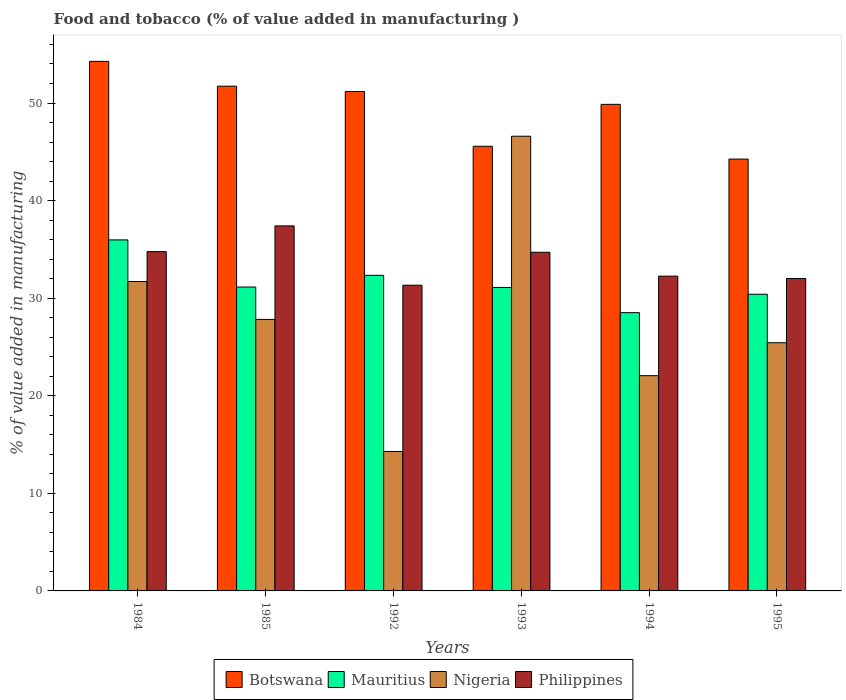How many bars are there on the 3rd tick from the right?
Make the answer very short. 4. What is the value added in manufacturing food and tobacco in Philippines in 1995?
Your answer should be very brief. 32.01. Across all years, what is the maximum value added in manufacturing food and tobacco in Nigeria?
Provide a short and direct response. 46.6. Across all years, what is the minimum value added in manufacturing food and tobacco in Mauritius?
Provide a succinct answer. 28.52. In which year was the value added in manufacturing food and tobacco in Mauritius maximum?
Your answer should be very brief. 1984. In which year was the value added in manufacturing food and tobacco in Mauritius minimum?
Provide a short and direct response. 1994. What is the total value added in manufacturing food and tobacco in Mauritius in the graph?
Your answer should be compact. 189.47. What is the difference between the value added in manufacturing food and tobacco in Philippines in 1985 and that in 1993?
Ensure brevity in your answer.  2.7. What is the difference between the value added in manufacturing food and tobacco in Botswana in 1992 and the value added in manufacturing food and tobacco in Mauritius in 1985?
Offer a very short reply. 20.04. What is the average value added in manufacturing food and tobacco in Nigeria per year?
Offer a very short reply. 27.99. In the year 1994, what is the difference between the value added in manufacturing food and tobacco in Nigeria and value added in manufacturing food and tobacco in Mauritius?
Make the answer very short. -6.46. What is the ratio of the value added in manufacturing food and tobacco in Philippines in 1985 to that in 1994?
Provide a short and direct response. 1.16. Is the value added in manufacturing food and tobacco in Mauritius in 1984 less than that in 1993?
Your answer should be very brief. No. Is the difference between the value added in manufacturing food and tobacco in Nigeria in 1992 and 1994 greater than the difference between the value added in manufacturing food and tobacco in Mauritius in 1992 and 1994?
Ensure brevity in your answer.  No. What is the difference between the highest and the second highest value added in manufacturing food and tobacco in Nigeria?
Keep it short and to the point. 14.89. What is the difference between the highest and the lowest value added in manufacturing food and tobacco in Nigeria?
Provide a short and direct response. 32.3. In how many years, is the value added in manufacturing food and tobacco in Nigeria greater than the average value added in manufacturing food and tobacco in Nigeria taken over all years?
Keep it short and to the point. 2. Is the sum of the value added in manufacturing food and tobacco in Botswana in 1993 and 1994 greater than the maximum value added in manufacturing food and tobacco in Philippines across all years?
Provide a short and direct response. Yes. What does the 3rd bar from the right in 1985 represents?
Offer a very short reply. Mauritius. Is it the case that in every year, the sum of the value added in manufacturing food and tobacco in Nigeria and value added in manufacturing food and tobacco in Botswana is greater than the value added in manufacturing food and tobacco in Mauritius?
Offer a very short reply. Yes. How many bars are there?
Your answer should be very brief. 24. How many years are there in the graph?
Ensure brevity in your answer.  6. What is the difference between two consecutive major ticks on the Y-axis?
Provide a short and direct response. 10. How many legend labels are there?
Your answer should be very brief. 4. How are the legend labels stacked?
Keep it short and to the point. Horizontal. What is the title of the graph?
Provide a short and direct response. Food and tobacco (% of value added in manufacturing ). What is the label or title of the Y-axis?
Provide a succinct answer. % of value added in manufacturing. What is the % of value added in manufacturing in Botswana in 1984?
Provide a succinct answer. 54.27. What is the % of value added in manufacturing in Mauritius in 1984?
Provide a succinct answer. 35.97. What is the % of value added in manufacturing of Nigeria in 1984?
Your answer should be compact. 31.71. What is the % of value added in manufacturing in Philippines in 1984?
Make the answer very short. 34.77. What is the % of value added in manufacturing of Botswana in 1985?
Your response must be concise. 51.72. What is the % of value added in manufacturing in Mauritius in 1985?
Your response must be concise. 31.14. What is the % of value added in manufacturing in Nigeria in 1985?
Offer a terse response. 27.82. What is the % of value added in manufacturing of Philippines in 1985?
Make the answer very short. 37.41. What is the % of value added in manufacturing of Botswana in 1992?
Give a very brief answer. 51.18. What is the % of value added in manufacturing of Mauritius in 1992?
Ensure brevity in your answer.  32.34. What is the % of value added in manufacturing in Nigeria in 1992?
Keep it short and to the point. 14.29. What is the % of value added in manufacturing in Philippines in 1992?
Provide a succinct answer. 31.33. What is the % of value added in manufacturing in Botswana in 1993?
Provide a succinct answer. 45.56. What is the % of value added in manufacturing in Mauritius in 1993?
Give a very brief answer. 31.1. What is the % of value added in manufacturing in Nigeria in 1993?
Ensure brevity in your answer.  46.6. What is the % of value added in manufacturing in Philippines in 1993?
Your answer should be compact. 34.7. What is the % of value added in manufacturing in Botswana in 1994?
Keep it short and to the point. 49.86. What is the % of value added in manufacturing in Mauritius in 1994?
Your response must be concise. 28.52. What is the % of value added in manufacturing in Nigeria in 1994?
Give a very brief answer. 22.06. What is the % of value added in manufacturing in Philippines in 1994?
Provide a succinct answer. 32.26. What is the % of value added in manufacturing of Botswana in 1995?
Your answer should be very brief. 44.26. What is the % of value added in manufacturing of Mauritius in 1995?
Keep it short and to the point. 30.4. What is the % of value added in manufacturing of Nigeria in 1995?
Ensure brevity in your answer.  25.43. What is the % of value added in manufacturing of Philippines in 1995?
Provide a succinct answer. 32.01. Across all years, what is the maximum % of value added in manufacturing in Botswana?
Ensure brevity in your answer.  54.27. Across all years, what is the maximum % of value added in manufacturing in Mauritius?
Keep it short and to the point. 35.97. Across all years, what is the maximum % of value added in manufacturing in Nigeria?
Offer a terse response. 46.6. Across all years, what is the maximum % of value added in manufacturing of Philippines?
Provide a short and direct response. 37.41. Across all years, what is the minimum % of value added in manufacturing in Botswana?
Provide a succinct answer. 44.26. Across all years, what is the minimum % of value added in manufacturing in Mauritius?
Your answer should be very brief. 28.52. Across all years, what is the minimum % of value added in manufacturing of Nigeria?
Make the answer very short. 14.29. Across all years, what is the minimum % of value added in manufacturing of Philippines?
Provide a short and direct response. 31.33. What is the total % of value added in manufacturing of Botswana in the graph?
Your answer should be compact. 296.85. What is the total % of value added in manufacturing of Mauritius in the graph?
Offer a terse response. 189.47. What is the total % of value added in manufacturing of Nigeria in the graph?
Give a very brief answer. 167.91. What is the total % of value added in manufacturing in Philippines in the graph?
Provide a succinct answer. 202.48. What is the difference between the % of value added in manufacturing of Botswana in 1984 and that in 1985?
Make the answer very short. 2.54. What is the difference between the % of value added in manufacturing of Mauritius in 1984 and that in 1985?
Your answer should be compact. 4.83. What is the difference between the % of value added in manufacturing of Nigeria in 1984 and that in 1985?
Ensure brevity in your answer.  3.88. What is the difference between the % of value added in manufacturing in Philippines in 1984 and that in 1985?
Keep it short and to the point. -2.64. What is the difference between the % of value added in manufacturing in Botswana in 1984 and that in 1992?
Make the answer very short. 3.09. What is the difference between the % of value added in manufacturing of Mauritius in 1984 and that in 1992?
Make the answer very short. 3.63. What is the difference between the % of value added in manufacturing in Nigeria in 1984 and that in 1992?
Your response must be concise. 17.42. What is the difference between the % of value added in manufacturing of Philippines in 1984 and that in 1992?
Provide a short and direct response. 3.44. What is the difference between the % of value added in manufacturing in Botswana in 1984 and that in 1993?
Offer a very short reply. 8.7. What is the difference between the % of value added in manufacturing of Mauritius in 1984 and that in 1993?
Provide a succinct answer. 4.87. What is the difference between the % of value added in manufacturing in Nigeria in 1984 and that in 1993?
Your answer should be very brief. -14.89. What is the difference between the % of value added in manufacturing of Philippines in 1984 and that in 1993?
Ensure brevity in your answer.  0.07. What is the difference between the % of value added in manufacturing of Botswana in 1984 and that in 1994?
Provide a succinct answer. 4.41. What is the difference between the % of value added in manufacturing of Mauritius in 1984 and that in 1994?
Offer a very short reply. 7.46. What is the difference between the % of value added in manufacturing of Nigeria in 1984 and that in 1994?
Keep it short and to the point. 9.65. What is the difference between the % of value added in manufacturing in Philippines in 1984 and that in 1994?
Your answer should be very brief. 2.51. What is the difference between the % of value added in manufacturing of Botswana in 1984 and that in 1995?
Your answer should be compact. 10.01. What is the difference between the % of value added in manufacturing of Mauritius in 1984 and that in 1995?
Provide a short and direct response. 5.57. What is the difference between the % of value added in manufacturing of Nigeria in 1984 and that in 1995?
Give a very brief answer. 6.27. What is the difference between the % of value added in manufacturing of Philippines in 1984 and that in 1995?
Make the answer very short. 2.76. What is the difference between the % of value added in manufacturing of Botswana in 1985 and that in 1992?
Offer a terse response. 0.55. What is the difference between the % of value added in manufacturing in Mauritius in 1985 and that in 1992?
Offer a very short reply. -1.2. What is the difference between the % of value added in manufacturing in Nigeria in 1985 and that in 1992?
Make the answer very short. 13.53. What is the difference between the % of value added in manufacturing in Philippines in 1985 and that in 1992?
Your response must be concise. 6.08. What is the difference between the % of value added in manufacturing in Botswana in 1985 and that in 1993?
Keep it short and to the point. 6.16. What is the difference between the % of value added in manufacturing in Mauritius in 1985 and that in 1993?
Keep it short and to the point. 0.04. What is the difference between the % of value added in manufacturing of Nigeria in 1985 and that in 1993?
Provide a succinct answer. -18.77. What is the difference between the % of value added in manufacturing in Philippines in 1985 and that in 1993?
Keep it short and to the point. 2.7. What is the difference between the % of value added in manufacturing in Botswana in 1985 and that in 1994?
Your answer should be compact. 1.86. What is the difference between the % of value added in manufacturing of Mauritius in 1985 and that in 1994?
Your response must be concise. 2.63. What is the difference between the % of value added in manufacturing of Nigeria in 1985 and that in 1994?
Provide a succinct answer. 5.77. What is the difference between the % of value added in manufacturing in Philippines in 1985 and that in 1994?
Provide a succinct answer. 5.15. What is the difference between the % of value added in manufacturing in Botswana in 1985 and that in 1995?
Your answer should be very brief. 7.47. What is the difference between the % of value added in manufacturing of Mauritius in 1985 and that in 1995?
Offer a terse response. 0.74. What is the difference between the % of value added in manufacturing in Nigeria in 1985 and that in 1995?
Provide a succinct answer. 2.39. What is the difference between the % of value added in manufacturing of Philippines in 1985 and that in 1995?
Your response must be concise. 5.39. What is the difference between the % of value added in manufacturing of Botswana in 1992 and that in 1993?
Keep it short and to the point. 5.61. What is the difference between the % of value added in manufacturing in Mauritius in 1992 and that in 1993?
Give a very brief answer. 1.24. What is the difference between the % of value added in manufacturing of Nigeria in 1992 and that in 1993?
Your response must be concise. -32.3. What is the difference between the % of value added in manufacturing in Philippines in 1992 and that in 1993?
Keep it short and to the point. -3.38. What is the difference between the % of value added in manufacturing in Botswana in 1992 and that in 1994?
Ensure brevity in your answer.  1.32. What is the difference between the % of value added in manufacturing of Mauritius in 1992 and that in 1994?
Your answer should be compact. 3.82. What is the difference between the % of value added in manufacturing of Nigeria in 1992 and that in 1994?
Provide a succinct answer. -7.77. What is the difference between the % of value added in manufacturing in Philippines in 1992 and that in 1994?
Make the answer very short. -0.93. What is the difference between the % of value added in manufacturing of Botswana in 1992 and that in 1995?
Offer a very short reply. 6.92. What is the difference between the % of value added in manufacturing of Mauritius in 1992 and that in 1995?
Provide a short and direct response. 1.94. What is the difference between the % of value added in manufacturing in Nigeria in 1992 and that in 1995?
Your answer should be compact. -11.14. What is the difference between the % of value added in manufacturing in Philippines in 1992 and that in 1995?
Offer a very short reply. -0.69. What is the difference between the % of value added in manufacturing of Botswana in 1993 and that in 1994?
Provide a succinct answer. -4.3. What is the difference between the % of value added in manufacturing of Mauritius in 1993 and that in 1994?
Your response must be concise. 2.59. What is the difference between the % of value added in manufacturing in Nigeria in 1993 and that in 1994?
Make the answer very short. 24.54. What is the difference between the % of value added in manufacturing in Philippines in 1993 and that in 1994?
Provide a short and direct response. 2.45. What is the difference between the % of value added in manufacturing of Botswana in 1993 and that in 1995?
Provide a short and direct response. 1.31. What is the difference between the % of value added in manufacturing of Mauritius in 1993 and that in 1995?
Your response must be concise. 0.7. What is the difference between the % of value added in manufacturing in Nigeria in 1993 and that in 1995?
Offer a terse response. 21.16. What is the difference between the % of value added in manufacturing in Philippines in 1993 and that in 1995?
Offer a terse response. 2.69. What is the difference between the % of value added in manufacturing in Botswana in 1994 and that in 1995?
Your response must be concise. 5.61. What is the difference between the % of value added in manufacturing of Mauritius in 1994 and that in 1995?
Your response must be concise. -1.89. What is the difference between the % of value added in manufacturing in Nigeria in 1994 and that in 1995?
Your answer should be very brief. -3.38. What is the difference between the % of value added in manufacturing of Philippines in 1994 and that in 1995?
Provide a short and direct response. 0.24. What is the difference between the % of value added in manufacturing of Botswana in 1984 and the % of value added in manufacturing of Mauritius in 1985?
Give a very brief answer. 23.13. What is the difference between the % of value added in manufacturing in Botswana in 1984 and the % of value added in manufacturing in Nigeria in 1985?
Your answer should be compact. 26.45. What is the difference between the % of value added in manufacturing in Botswana in 1984 and the % of value added in manufacturing in Philippines in 1985?
Make the answer very short. 16.86. What is the difference between the % of value added in manufacturing in Mauritius in 1984 and the % of value added in manufacturing in Nigeria in 1985?
Provide a succinct answer. 8.15. What is the difference between the % of value added in manufacturing of Mauritius in 1984 and the % of value added in manufacturing of Philippines in 1985?
Your answer should be compact. -1.43. What is the difference between the % of value added in manufacturing of Nigeria in 1984 and the % of value added in manufacturing of Philippines in 1985?
Make the answer very short. -5.7. What is the difference between the % of value added in manufacturing in Botswana in 1984 and the % of value added in manufacturing in Mauritius in 1992?
Make the answer very short. 21.93. What is the difference between the % of value added in manufacturing in Botswana in 1984 and the % of value added in manufacturing in Nigeria in 1992?
Your response must be concise. 39.98. What is the difference between the % of value added in manufacturing of Botswana in 1984 and the % of value added in manufacturing of Philippines in 1992?
Make the answer very short. 22.94. What is the difference between the % of value added in manufacturing in Mauritius in 1984 and the % of value added in manufacturing in Nigeria in 1992?
Your response must be concise. 21.68. What is the difference between the % of value added in manufacturing of Mauritius in 1984 and the % of value added in manufacturing of Philippines in 1992?
Provide a short and direct response. 4.64. What is the difference between the % of value added in manufacturing in Nigeria in 1984 and the % of value added in manufacturing in Philippines in 1992?
Keep it short and to the point. 0.38. What is the difference between the % of value added in manufacturing in Botswana in 1984 and the % of value added in manufacturing in Mauritius in 1993?
Offer a very short reply. 23.17. What is the difference between the % of value added in manufacturing of Botswana in 1984 and the % of value added in manufacturing of Nigeria in 1993?
Your response must be concise. 7.67. What is the difference between the % of value added in manufacturing in Botswana in 1984 and the % of value added in manufacturing in Philippines in 1993?
Provide a short and direct response. 19.56. What is the difference between the % of value added in manufacturing of Mauritius in 1984 and the % of value added in manufacturing of Nigeria in 1993?
Your answer should be compact. -10.62. What is the difference between the % of value added in manufacturing in Mauritius in 1984 and the % of value added in manufacturing in Philippines in 1993?
Give a very brief answer. 1.27. What is the difference between the % of value added in manufacturing of Nigeria in 1984 and the % of value added in manufacturing of Philippines in 1993?
Provide a short and direct response. -3. What is the difference between the % of value added in manufacturing in Botswana in 1984 and the % of value added in manufacturing in Mauritius in 1994?
Give a very brief answer. 25.75. What is the difference between the % of value added in manufacturing in Botswana in 1984 and the % of value added in manufacturing in Nigeria in 1994?
Your response must be concise. 32.21. What is the difference between the % of value added in manufacturing of Botswana in 1984 and the % of value added in manufacturing of Philippines in 1994?
Keep it short and to the point. 22.01. What is the difference between the % of value added in manufacturing of Mauritius in 1984 and the % of value added in manufacturing of Nigeria in 1994?
Make the answer very short. 13.91. What is the difference between the % of value added in manufacturing in Mauritius in 1984 and the % of value added in manufacturing in Philippines in 1994?
Offer a very short reply. 3.71. What is the difference between the % of value added in manufacturing of Nigeria in 1984 and the % of value added in manufacturing of Philippines in 1994?
Provide a short and direct response. -0.55. What is the difference between the % of value added in manufacturing of Botswana in 1984 and the % of value added in manufacturing of Mauritius in 1995?
Offer a very short reply. 23.87. What is the difference between the % of value added in manufacturing of Botswana in 1984 and the % of value added in manufacturing of Nigeria in 1995?
Provide a succinct answer. 28.83. What is the difference between the % of value added in manufacturing of Botswana in 1984 and the % of value added in manufacturing of Philippines in 1995?
Your answer should be very brief. 22.25. What is the difference between the % of value added in manufacturing in Mauritius in 1984 and the % of value added in manufacturing in Nigeria in 1995?
Make the answer very short. 10.54. What is the difference between the % of value added in manufacturing in Mauritius in 1984 and the % of value added in manufacturing in Philippines in 1995?
Make the answer very short. 3.96. What is the difference between the % of value added in manufacturing in Nigeria in 1984 and the % of value added in manufacturing in Philippines in 1995?
Give a very brief answer. -0.31. What is the difference between the % of value added in manufacturing of Botswana in 1985 and the % of value added in manufacturing of Mauritius in 1992?
Offer a terse response. 19.38. What is the difference between the % of value added in manufacturing in Botswana in 1985 and the % of value added in manufacturing in Nigeria in 1992?
Offer a very short reply. 37.43. What is the difference between the % of value added in manufacturing in Botswana in 1985 and the % of value added in manufacturing in Philippines in 1992?
Your answer should be very brief. 20.4. What is the difference between the % of value added in manufacturing in Mauritius in 1985 and the % of value added in manufacturing in Nigeria in 1992?
Keep it short and to the point. 16.85. What is the difference between the % of value added in manufacturing in Mauritius in 1985 and the % of value added in manufacturing in Philippines in 1992?
Give a very brief answer. -0.19. What is the difference between the % of value added in manufacturing in Nigeria in 1985 and the % of value added in manufacturing in Philippines in 1992?
Offer a very short reply. -3.5. What is the difference between the % of value added in manufacturing of Botswana in 1985 and the % of value added in manufacturing of Mauritius in 1993?
Your answer should be compact. 20.62. What is the difference between the % of value added in manufacturing of Botswana in 1985 and the % of value added in manufacturing of Nigeria in 1993?
Provide a short and direct response. 5.13. What is the difference between the % of value added in manufacturing in Botswana in 1985 and the % of value added in manufacturing in Philippines in 1993?
Your response must be concise. 17.02. What is the difference between the % of value added in manufacturing of Mauritius in 1985 and the % of value added in manufacturing of Nigeria in 1993?
Provide a succinct answer. -15.46. What is the difference between the % of value added in manufacturing in Mauritius in 1985 and the % of value added in manufacturing in Philippines in 1993?
Provide a short and direct response. -3.56. What is the difference between the % of value added in manufacturing in Nigeria in 1985 and the % of value added in manufacturing in Philippines in 1993?
Make the answer very short. -6.88. What is the difference between the % of value added in manufacturing in Botswana in 1985 and the % of value added in manufacturing in Mauritius in 1994?
Your response must be concise. 23.21. What is the difference between the % of value added in manufacturing in Botswana in 1985 and the % of value added in manufacturing in Nigeria in 1994?
Ensure brevity in your answer.  29.67. What is the difference between the % of value added in manufacturing in Botswana in 1985 and the % of value added in manufacturing in Philippines in 1994?
Ensure brevity in your answer.  19.47. What is the difference between the % of value added in manufacturing of Mauritius in 1985 and the % of value added in manufacturing of Nigeria in 1994?
Provide a short and direct response. 9.08. What is the difference between the % of value added in manufacturing of Mauritius in 1985 and the % of value added in manufacturing of Philippines in 1994?
Your response must be concise. -1.12. What is the difference between the % of value added in manufacturing in Nigeria in 1985 and the % of value added in manufacturing in Philippines in 1994?
Offer a terse response. -4.44. What is the difference between the % of value added in manufacturing of Botswana in 1985 and the % of value added in manufacturing of Mauritius in 1995?
Your answer should be compact. 21.32. What is the difference between the % of value added in manufacturing in Botswana in 1985 and the % of value added in manufacturing in Nigeria in 1995?
Your answer should be compact. 26.29. What is the difference between the % of value added in manufacturing in Botswana in 1985 and the % of value added in manufacturing in Philippines in 1995?
Keep it short and to the point. 19.71. What is the difference between the % of value added in manufacturing of Mauritius in 1985 and the % of value added in manufacturing of Nigeria in 1995?
Give a very brief answer. 5.71. What is the difference between the % of value added in manufacturing in Mauritius in 1985 and the % of value added in manufacturing in Philippines in 1995?
Provide a short and direct response. -0.87. What is the difference between the % of value added in manufacturing in Nigeria in 1985 and the % of value added in manufacturing in Philippines in 1995?
Your answer should be compact. -4.19. What is the difference between the % of value added in manufacturing of Botswana in 1992 and the % of value added in manufacturing of Mauritius in 1993?
Your answer should be compact. 20.08. What is the difference between the % of value added in manufacturing of Botswana in 1992 and the % of value added in manufacturing of Nigeria in 1993?
Give a very brief answer. 4.58. What is the difference between the % of value added in manufacturing of Botswana in 1992 and the % of value added in manufacturing of Philippines in 1993?
Your answer should be compact. 16.47. What is the difference between the % of value added in manufacturing of Mauritius in 1992 and the % of value added in manufacturing of Nigeria in 1993?
Offer a very short reply. -14.26. What is the difference between the % of value added in manufacturing of Mauritius in 1992 and the % of value added in manufacturing of Philippines in 1993?
Offer a very short reply. -2.36. What is the difference between the % of value added in manufacturing of Nigeria in 1992 and the % of value added in manufacturing of Philippines in 1993?
Your answer should be compact. -20.41. What is the difference between the % of value added in manufacturing of Botswana in 1992 and the % of value added in manufacturing of Mauritius in 1994?
Make the answer very short. 22.66. What is the difference between the % of value added in manufacturing of Botswana in 1992 and the % of value added in manufacturing of Nigeria in 1994?
Provide a short and direct response. 29.12. What is the difference between the % of value added in manufacturing of Botswana in 1992 and the % of value added in manufacturing of Philippines in 1994?
Keep it short and to the point. 18.92. What is the difference between the % of value added in manufacturing in Mauritius in 1992 and the % of value added in manufacturing in Nigeria in 1994?
Provide a short and direct response. 10.28. What is the difference between the % of value added in manufacturing of Mauritius in 1992 and the % of value added in manufacturing of Philippines in 1994?
Your answer should be compact. 0.08. What is the difference between the % of value added in manufacturing of Nigeria in 1992 and the % of value added in manufacturing of Philippines in 1994?
Give a very brief answer. -17.97. What is the difference between the % of value added in manufacturing in Botswana in 1992 and the % of value added in manufacturing in Mauritius in 1995?
Offer a terse response. 20.78. What is the difference between the % of value added in manufacturing of Botswana in 1992 and the % of value added in manufacturing of Nigeria in 1995?
Give a very brief answer. 25.74. What is the difference between the % of value added in manufacturing in Botswana in 1992 and the % of value added in manufacturing in Philippines in 1995?
Make the answer very short. 19.16. What is the difference between the % of value added in manufacturing of Mauritius in 1992 and the % of value added in manufacturing of Nigeria in 1995?
Your answer should be compact. 6.91. What is the difference between the % of value added in manufacturing of Mauritius in 1992 and the % of value added in manufacturing of Philippines in 1995?
Ensure brevity in your answer.  0.33. What is the difference between the % of value added in manufacturing in Nigeria in 1992 and the % of value added in manufacturing in Philippines in 1995?
Give a very brief answer. -17.72. What is the difference between the % of value added in manufacturing of Botswana in 1993 and the % of value added in manufacturing of Mauritius in 1994?
Make the answer very short. 17.05. What is the difference between the % of value added in manufacturing in Botswana in 1993 and the % of value added in manufacturing in Nigeria in 1994?
Your answer should be compact. 23.51. What is the difference between the % of value added in manufacturing in Botswana in 1993 and the % of value added in manufacturing in Philippines in 1994?
Keep it short and to the point. 13.31. What is the difference between the % of value added in manufacturing of Mauritius in 1993 and the % of value added in manufacturing of Nigeria in 1994?
Make the answer very short. 9.04. What is the difference between the % of value added in manufacturing in Mauritius in 1993 and the % of value added in manufacturing in Philippines in 1994?
Your answer should be compact. -1.16. What is the difference between the % of value added in manufacturing in Nigeria in 1993 and the % of value added in manufacturing in Philippines in 1994?
Make the answer very short. 14.34. What is the difference between the % of value added in manufacturing of Botswana in 1993 and the % of value added in manufacturing of Mauritius in 1995?
Your response must be concise. 15.16. What is the difference between the % of value added in manufacturing in Botswana in 1993 and the % of value added in manufacturing in Nigeria in 1995?
Your answer should be compact. 20.13. What is the difference between the % of value added in manufacturing of Botswana in 1993 and the % of value added in manufacturing of Philippines in 1995?
Your answer should be compact. 13.55. What is the difference between the % of value added in manufacturing in Mauritius in 1993 and the % of value added in manufacturing in Nigeria in 1995?
Make the answer very short. 5.67. What is the difference between the % of value added in manufacturing in Mauritius in 1993 and the % of value added in manufacturing in Philippines in 1995?
Give a very brief answer. -0.91. What is the difference between the % of value added in manufacturing in Nigeria in 1993 and the % of value added in manufacturing in Philippines in 1995?
Give a very brief answer. 14.58. What is the difference between the % of value added in manufacturing in Botswana in 1994 and the % of value added in manufacturing in Mauritius in 1995?
Your answer should be compact. 19.46. What is the difference between the % of value added in manufacturing in Botswana in 1994 and the % of value added in manufacturing in Nigeria in 1995?
Give a very brief answer. 24.43. What is the difference between the % of value added in manufacturing in Botswana in 1994 and the % of value added in manufacturing in Philippines in 1995?
Keep it short and to the point. 17.85. What is the difference between the % of value added in manufacturing in Mauritius in 1994 and the % of value added in manufacturing in Nigeria in 1995?
Provide a succinct answer. 3.08. What is the difference between the % of value added in manufacturing in Mauritius in 1994 and the % of value added in manufacturing in Philippines in 1995?
Ensure brevity in your answer.  -3.5. What is the difference between the % of value added in manufacturing of Nigeria in 1994 and the % of value added in manufacturing of Philippines in 1995?
Ensure brevity in your answer.  -9.96. What is the average % of value added in manufacturing of Botswana per year?
Provide a succinct answer. 49.48. What is the average % of value added in manufacturing of Mauritius per year?
Provide a succinct answer. 31.58. What is the average % of value added in manufacturing of Nigeria per year?
Ensure brevity in your answer.  27.99. What is the average % of value added in manufacturing in Philippines per year?
Give a very brief answer. 33.75. In the year 1984, what is the difference between the % of value added in manufacturing in Botswana and % of value added in manufacturing in Mauritius?
Make the answer very short. 18.3. In the year 1984, what is the difference between the % of value added in manufacturing in Botswana and % of value added in manufacturing in Nigeria?
Provide a succinct answer. 22.56. In the year 1984, what is the difference between the % of value added in manufacturing of Botswana and % of value added in manufacturing of Philippines?
Make the answer very short. 19.5. In the year 1984, what is the difference between the % of value added in manufacturing of Mauritius and % of value added in manufacturing of Nigeria?
Offer a terse response. 4.26. In the year 1984, what is the difference between the % of value added in manufacturing of Mauritius and % of value added in manufacturing of Philippines?
Offer a terse response. 1.2. In the year 1984, what is the difference between the % of value added in manufacturing of Nigeria and % of value added in manufacturing of Philippines?
Your answer should be compact. -3.06. In the year 1985, what is the difference between the % of value added in manufacturing in Botswana and % of value added in manufacturing in Mauritius?
Your response must be concise. 20.58. In the year 1985, what is the difference between the % of value added in manufacturing of Botswana and % of value added in manufacturing of Nigeria?
Ensure brevity in your answer.  23.9. In the year 1985, what is the difference between the % of value added in manufacturing in Botswana and % of value added in manufacturing in Philippines?
Ensure brevity in your answer.  14.32. In the year 1985, what is the difference between the % of value added in manufacturing of Mauritius and % of value added in manufacturing of Nigeria?
Keep it short and to the point. 3.32. In the year 1985, what is the difference between the % of value added in manufacturing of Mauritius and % of value added in manufacturing of Philippines?
Your response must be concise. -6.26. In the year 1985, what is the difference between the % of value added in manufacturing in Nigeria and % of value added in manufacturing in Philippines?
Provide a short and direct response. -9.58. In the year 1992, what is the difference between the % of value added in manufacturing in Botswana and % of value added in manufacturing in Mauritius?
Make the answer very short. 18.84. In the year 1992, what is the difference between the % of value added in manufacturing in Botswana and % of value added in manufacturing in Nigeria?
Offer a very short reply. 36.89. In the year 1992, what is the difference between the % of value added in manufacturing of Botswana and % of value added in manufacturing of Philippines?
Your answer should be compact. 19.85. In the year 1992, what is the difference between the % of value added in manufacturing in Mauritius and % of value added in manufacturing in Nigeria?
Give a very brief answer. 18.05. In the year 1992, what is the difference between the % of value added in manufacturing of Nigeria and % of value added in manufacturing of Philippines?
Make the answer very short. -17.04. In the year 1993, what is the difference between the % of value added in manufacturing in Botswana and % of value added in manufacturing in Mauritius?
Your answer should be very brief. 14.46. In the year 1993, what is the difference between the % of value added in manufacturing in Botswana and % of value added in manufacturing in Nigeria?
Your response must be concise. -1.03. In the year 1993, what is the difference between the % of value added in manufacturing in Botswana and % of value added in manufacturing in Philippines?
Offer a terse response. 10.86. In the year 1993, what is the difference between the % of value added in manufacturing of Mauritius and % of value added in manufacturing of Nigeria?
Make the answer very short. -15.5. In the year 1993, what is the difference between the % of value added in manufacturing of Mauritius and % of value added in manufacturing of Philippines?
Ensure brevity in your answer.  -3.6. In the year 1993, what is the difference between the % of value added in manufacturing of Nigeria and % of value added in manufacturing of Philippines?
Keep it short and to the point. 11.89. In the year 1994, what is the difference between the % of value added in manufacturing in Botswana and % of value added in manufacturing in Mauritius?
Keep it short and to the point. 21.35. In the year 1994, what is the difference between the % of value added in manufacturing of Botswana and % of value added in manufacturing of Nigeria?
Your response must be concise. 27.8. In the year 1994, what is the difference between the % of value added in manufacturing in Botswana and % of value added in manufacturing in Philippines?
Offer a very short reply. 17.6. In the year 1994, what is the difference between the % of value added in manufacturing in Mauritius and % of value added in manufacturing in Nigeria?
Offer a terse response. 6.46. In the year 1994, what is the difference between the % of value added in manufacturing in Mauritius and % of value added in manufacturing in Philippines?
Your answer should be compact. -3.74. In the year 1994, what is the difference between the % of value added in manufacturing of Nigeria and % of value added in manufacturing of Philippines?
Give a very brief answer. -10.2. In the year 1995, what is the difference between the % of value added in manufacturing in Botswana and % of value added in manufacturing in Mauritius?
Your response must be concise. 13.85. In the year 1995, what is the difference between the % of value added in manufacturing in Botswana and % of value added in manufacturing in Nigeria?
Your answer should be compact. 18.82. In the year 1995, what is the difference between the % of value added in manufacturing of Botswana and % of value added in manufacturing of Philippines?
Your answer should be very brief. 12.24. In the year 1995, what is the difference between the % of value added in manufacturing in Mauritius and % of value added in manufacturing in Nigeria?
Offer a very short reply. 4.97. In the year 1995, what is the difference between the % of value added in manufacturing of Mauritius and % of value added in manufacturing of Philippines?
Make the answer very short. -1.61. In the year 1995, what is the difference between the % of value added in manufacturing of Nigeria and % of value added in manufacturing of Philippines?
Give a very brief answer. -6.58. What is the ratio of the % of value added in manufacturing of Botswana in 1984 to that in 1985?
Provide a short and direct response. 1.05. What is the ratio of the % of value added in manufacturing in Mauritius in 1984 to that in 1985?
Your response must be concise. 1.16. What is the ratio of the % of value added in manufacturing of Nigeria in 1984 to that in 1985?
Offer a terse response. 1.14. What is the ratio of the % of value added in manufacturing of Philippines in 1984 to that in 1985?
Make the answer very short. 0.93. What is the ratio of the % of value added in manufacturing in Botswana in 1984 to that in 1992?
Offer a terse response. 1.06. What is the ratio of the % of value added in manufacturing of Mauritius in 1984 to that in 1992?
Provide a short and direct response. 1.11. What is the ratio of the % of value added in manufacturing in Nigeria in 1984 to that in 1992?
Provide a succinct answer. 2.22. What is the ratio of the % of value added in manufacturing of Philippines in 1984 to that in 1992?
Keep it short and to the point. 1.11. What is the ratio of the % of value added in manufacturing of Botswana in 1984 to that in 1993?
Offer a very short reply. 1.19. What is the ratio of the % of value added in manufacturing in Mauritius in 1984 to that in 1993?
Provide a succinct answer. 1.16. What is the ratio of the % of value added in manufacturing of Nigeria in 1984 to that in 1993?
Offer a very short reply. 0.68. What is the ratio of the % of value added in manufacturing of Botswana in 1984 to that in 1994?
Offer a very short reply. 1.09. What is the ratio of the % of value added in manufacturing in Mauritius in 1984 to that in 1994?
Provide a succinct answer. 1.26. What is the ratio of the % of value added in manufacturing in Nigeria in 1984 to that in 1994?
Your response must be concise. 1.44. What is the ratio of the % of value added in manufacturing of Philippines in 1984 to that in 1994?
Offer a very short reply. 1.08. What is the ratio of the % of value added in manufacturing in Botswana in 1984 to that in 1995?
Give a very brief answer. 1.23. What is the ratio of the % of value added in manufacturing of Mauritius in 1984 to that in 1995?
Ensure brevity in your answer.  1.18. What is the ratio of the % of value added in manufacturing of Nigeria in 1984 to that in 1995?
Offer a very short reply. 1.25. What is the ratio of the % of value added in manufacturing of Philippines in 1984 to that in 1995?
Ensure brevity in your answer.  1.09. What is the ratio of the % of value added in manufacturing in Botswana in 1985 to that in 1992?
Provide a succinct answer. 1.01. What is the ratio of the % of value added in manufacturing of Mauritius in 1985 to that in 1992?
Make the answer very short. 0.96. What is the ratio of the % of value added in manufacturing in Nigeria in 1985 to that in 1992?
Make the answer very short. 1.95. What is the ratio of the % of value added in manufacturing in Philippines in 1985 to that in 1992?
Make the answer very short. 1.19. What is the ratio of the % of value added in manufacturing of Botswana in 1985 to that in 1993?
Ensure brevity in your answer.  1.14. What is the ratio of the % of value added in manufacturing in Nigeria in 1985 to that in 1993?
Keep it short and to the point. 0.6. What is the ratio of the % of value added in manufacturing of Philippines in 1985 to that in 1993?
Keep it short and to the point. 1.08. What is the ratio of the % of value added in manufacturing in Botswana in 1985 to that in 1994?
Ensure brevity in your answer.  1.04. What is the ratio of the % of value added in manufacturing in Mauritius in 1985 to that in 1994?
Provide a succinct answer. 1.09. What is the ratio of the % of value added in manufacturing in Nigeria in 1985 to that in 1994?
Make the answer very short. 1.26. What is the ratio of the % of value added in manufacturing of Philippines in 1985 to that in 1994?
Offer a terse response. 1.16. What is the ratio of the % of value added in manufacturing in Botswana in 1985 to that in 1995?
Offer a terse response. 1.17. What is the ratio of the % of value added in manufacturing in Mauritius in 1985 to that in 1995?
Your answer should be compact. 1.02. What is the ratio of the % of value added in manufacturing of Nigeria in 1985 to that in 1995?
Offer a very short reply. 1.09. What is the ratio of the % of value added in manufacturing of Philippines in 1985 to that in 1995?
Offer a very short reply. 1.17. What is the ratio of the % of value added in manufacturing of Botswana in 1992 to that in 1993?
Provide a succinct answer. 1.12. What is the ratio of the % of value added in manufacturing of Mauritius in 1992 to that in 1993?
Keep it short and to the point. 1.04. What is the ratio of the % of value added in manufacturing in Nigeria in 1992 to that in 1993?
Provide a succinct answer. 0.31. What is the ratio of the % of value added in manufacturing in Philippines in 1992 to that in 1993?
Offer a very short reply. 0.9. What is the ratio of the % of value added in manufacturing of Botswana in 1992 to that in 1994?
Your response must be concise. 1.03. What is the ratio of the % of value added in manufacturing of Mauritius in 1992 to that in 1994?
Provide a short and direct response. 1.13. What is the ratio of the % of value added in manufacturing in Nigeria in 1992 to that in 1994?
Provide a short and direct response. 0.65. What is the ratio of the % of value added in manufacturing in Philippines in 1992 to that in 1994?
Your answer should be compact. 0.97. What is the ratio of the % of value added in manufacturing in Botswana in 1992 to that in 1995?
Give a very brief answer. 1.16. What is the ratio of the % of value added in manufacturing in Mauritius in 1992 to that in 1995?
Give a very brief answer. 1.06. What is the ratio of the % of value added in manufacturing in Nigeria in 1992 to that in 1995?
Your answer should be very brief. 0.56. What is the ratio of the % of value added in manufacturing of Philippines in 1992 to that in 1995?
Keep it short and to the point. 0.98. What is the ratio of the % of value added in manufacturing in Botswana in 1993 to that in 1994?
Offer a very short reply. 0.91. What is the ratio of the % of value added in manufacturing in Mauritius in 1993 to that in 1994?
Your answer should be compact. 1.09. What is the ratio of the % of value added in manufacturing of Nigeria in 1993 to that in 1994?
Offer a terse response. 2.11. What is the ratio of the % of value added in manufacturing of Philippines in 1993 to that in 1994?
Offer a very short reply. 1.08. What is the ratio of the % of value added in manufacturing of Botswana in 1993 to that in 1995?
Ensure brevity in your answer.  1.03. What is the ratio of the % of value added in manufacturing of Nigeria in 1993 to that in 1995?
Give a very brief answer. 1.83. What is the ratio of the % of value added in manufacturing in Philippines in 1993 to that in 1995?
Offer a terse response. 1.08. What is the ratio of the % of value added in manufacturing of Botswana in 1994 to that in 1995?
Your answer should be very brief. 1.13. What is the ratio of the % of value added in manufacturing in Mauritius in 1994 to that in 1995?
Offer a very short reply. 0.94. What is the ratio of the % of value added in manufacturing in Nigeria in 1994 to that in 1995?
Ensure brevity in your answer.  0.87. What is the ratio of the % of value added in manufacturing in Philippines in 1994 to that in 1995?
Your answer should be compact. 1.01. What is the difference between the highest and the second highest % of value added in manufacturing of Botswana?
Your answer should be very brief. 2.54. What is the difference between the highest and the second highest % of value added in manufacturing of Mauritius?
Provide a short and direct response. 3.63. What is the difference between the highest and the second highest % of value added in manufacturing of Nigeria?
Offer a terse response. 14.89. What is the difference between the highest and the second highest % of value added in manufacturing in Philippines?
Your response must be concise. 2.64. What is the difference between the highest and the lowest % of value added in manufacturing of Botswana?
Keep it short and to the point. 10.01. What is the difference between the highest and the lowest % of value added in manufacturing of Mauritius?
Keep it short and to the point. 7.46. What is the difference between the highest and the lowest % of value added in manufacturing of Nigeria?
Give a very brief answer. 32.3. What is the difference between the highest and the lowest % of value added in manufacturing of Philippines?
Provide a succinct answer. 6.08. 